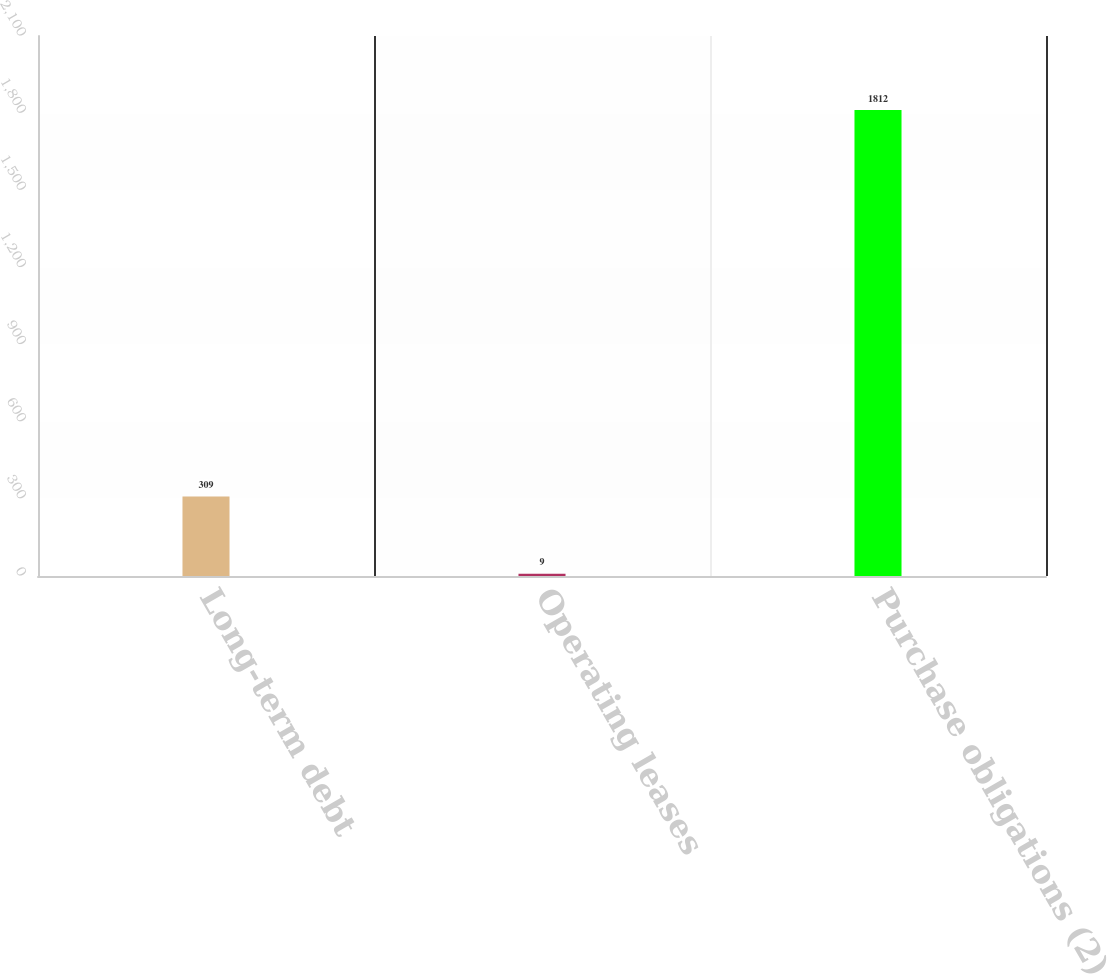<chart> <loc_0><loc_0><loc_500><loc_500><bar_chart><fcel>Long-term debt<fcel>Operating leases<fcel>Purchase obligations (2)<nl><fcel>309<fcel>9<fcel>1812<nl></chart> 